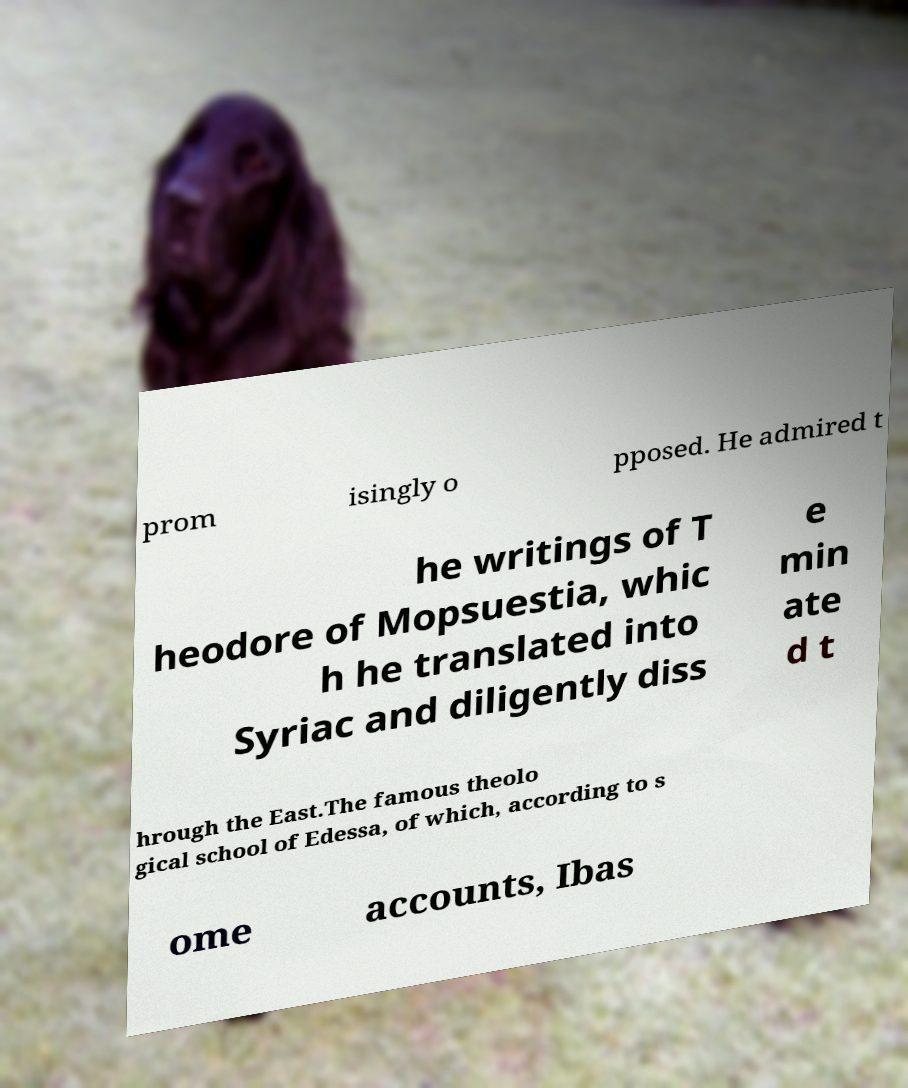Please read and relay the text visible in this image. What does it say? prom isingly o pposed. He admired t he writings of T heodore of Mopsuestia, whic h he translated into Syriac and diligently diss e min ate d t hrough the East.The famous theolo gical school of Edessa, of which, according to s ome accounts, Ibas 